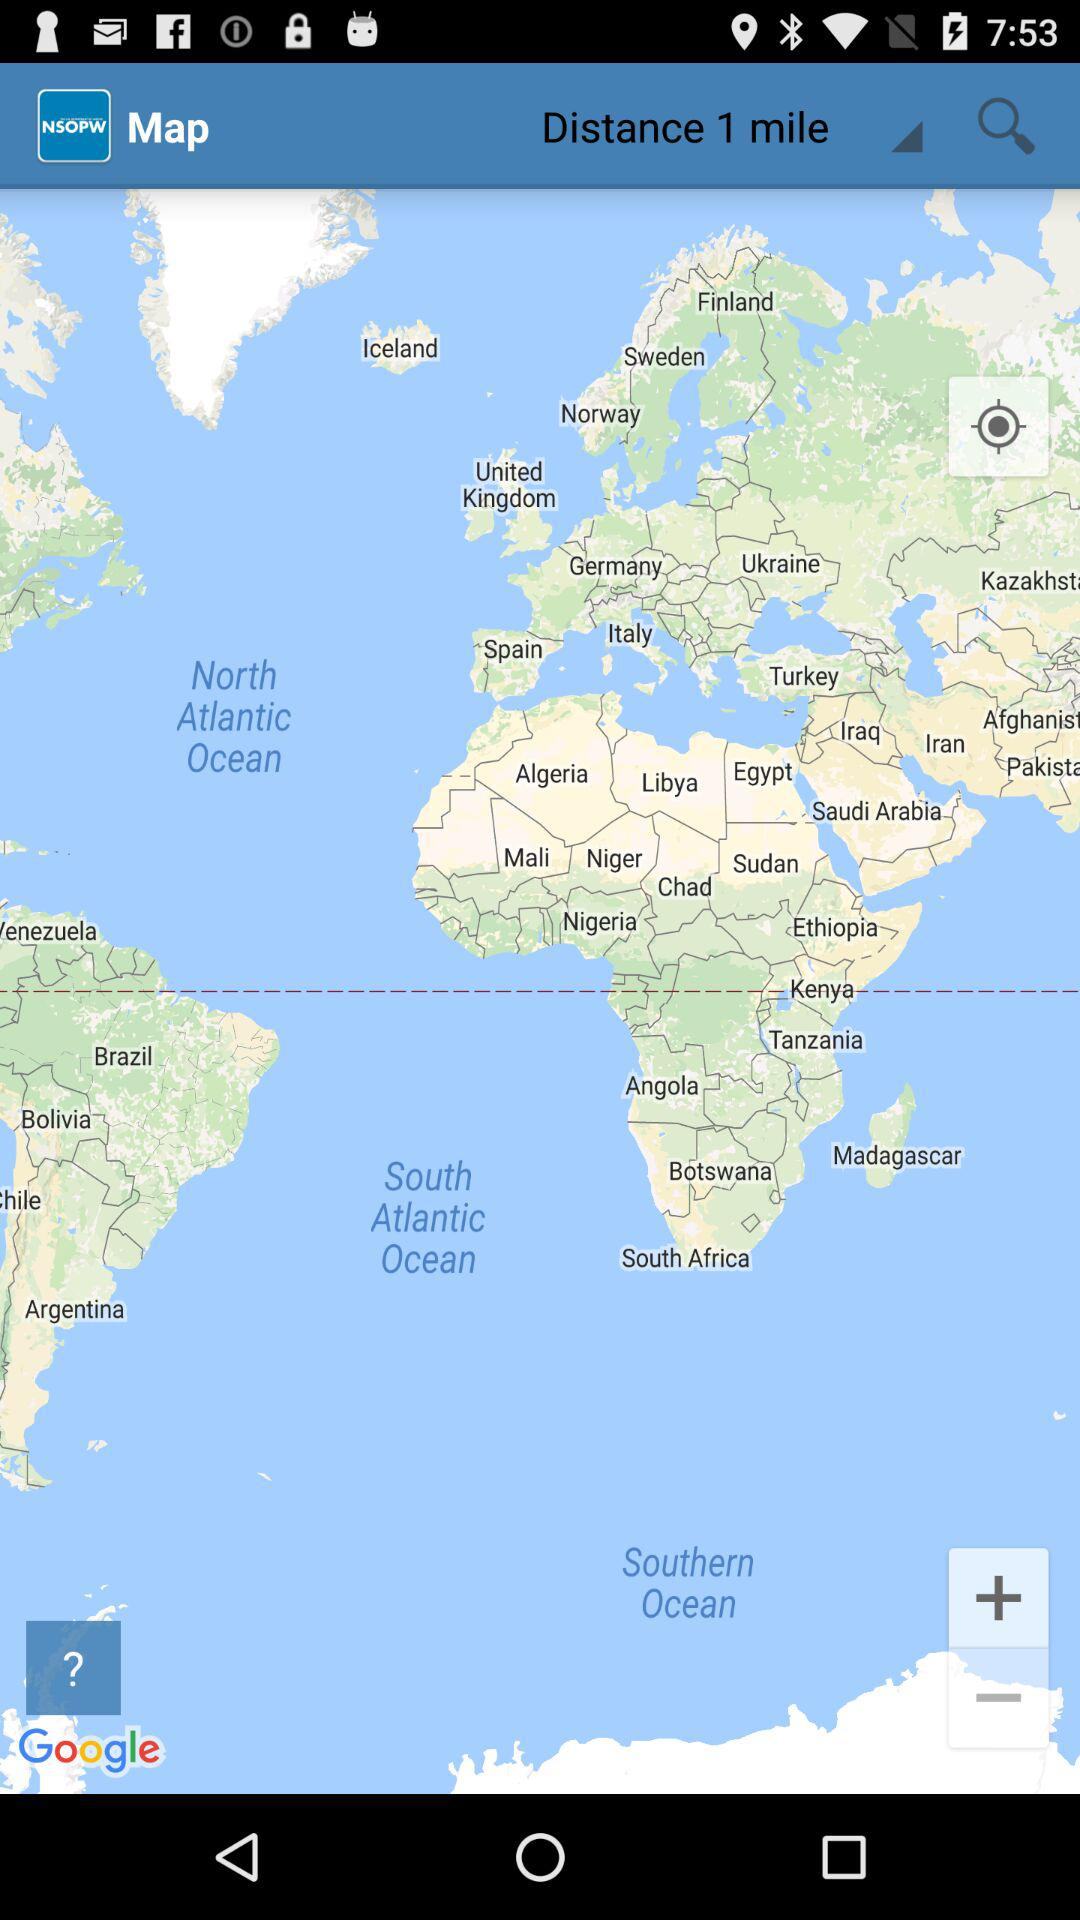What is the distance selected on the screen? The selected distance on the screen is 1 mile. 